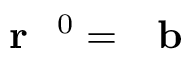<formula> <loc_0><loc_0><loc_500><loc_500>r ^ { 0 } = b</formula> 